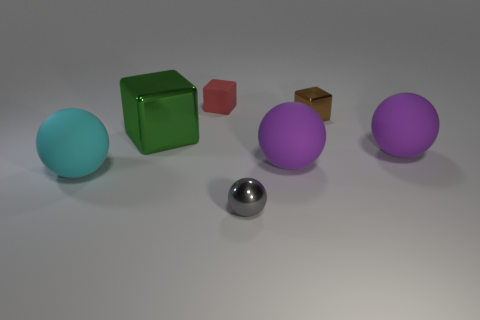Subtract all tiny gray spheres. How many spheres are left? 3 Subtract all gray balls. How many balls are left? 3 Subtract all green spheres. Subtract all cyan blocks. How many spheres are left? 4 Add 3 green shiny things. How many objects exist? 10 Subtract 0 yellow spheres. How many objects are left? 7 Subtract all cubes. How many objects are left? 4 Subtract all big green objects. Subtract all tiny matte cubes. How many objects are left? 5 Add 3 small gray shiny balls. How many small gray shiny balls are left? 4 Add 6 green cylinders. How many green cylinders exist? 6 